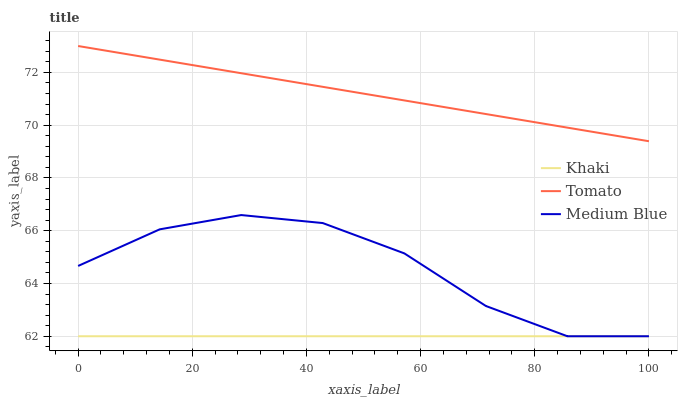Does Khaki have the minimum area under the curve?
Answer yes or no. Yes. Does Tomato have the maximum area under the curve?
Answer yes or no. Yes. Does Medium Blue have the minimum area under the curve?
Answer yes or no. No. Does Medium Blue have the maximum area under the curve?
Answer yes or no. No. Is Khaki the smoothest?
Answer yes or no. Yes. Is Medium Blue the roughest?
Answer yes or no. Yes. Is Medium Blue the smoothest?
Answer yes or no. No. Is Khaki the roughest?
Answer yes or no. No. Does Khaki have the lowest value?
Answer yes or no. Yes. Does Tomato have the highest value?
Answer yes or no. Yes. Does Medium Blue have the highest value?
Answer yes or no. No. Is Medium Blue less than Tomato?
Answer yes or no. Yes. Is Tomato greater than Khaki?
Answer yes or no. Yes. Does Khaki intersect Medium Blue?
Answer yes or no. Yes. Is Khaki less than Medium Blue?
Answer yes or no. No. Is Khaki greater than Medium Blue?
Answer yes or no. No. Does Medium Blue intersect Tomato?
Answer yes or no. No. 